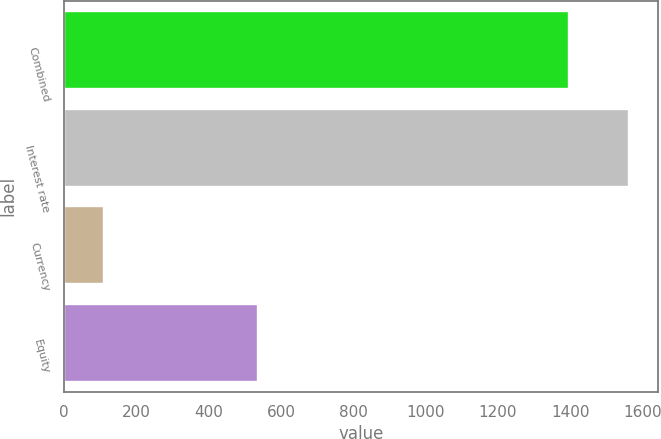Convert chart. <chart><loc_0><loc_0><loc_500><loc_500><bar_chart><fcel>Combined<fcel>Interest rate<fcel>Currency<fcel>Equity<nl><fcel>1396<fcel>1563<fcel>111<fcel>535<nl></chart> 